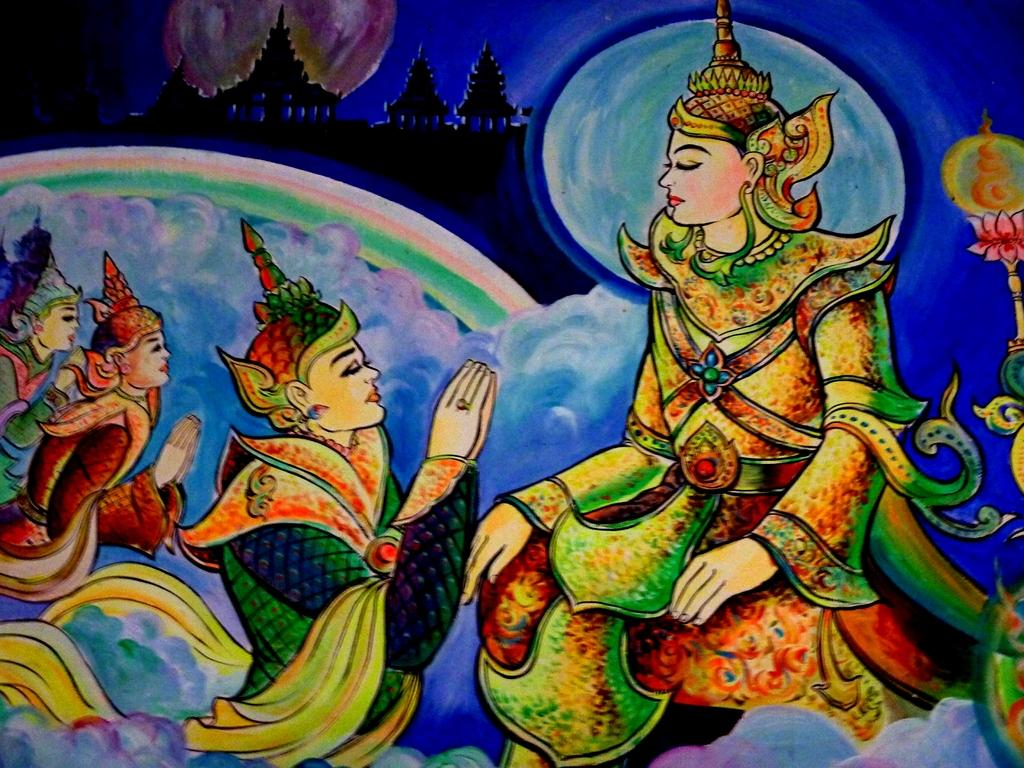What is the main subject of the image? There is a painting in the image. What type of whip is being advertised in the painting? There is no whip or advertisement present in the painting; it is the main subject of the image. 